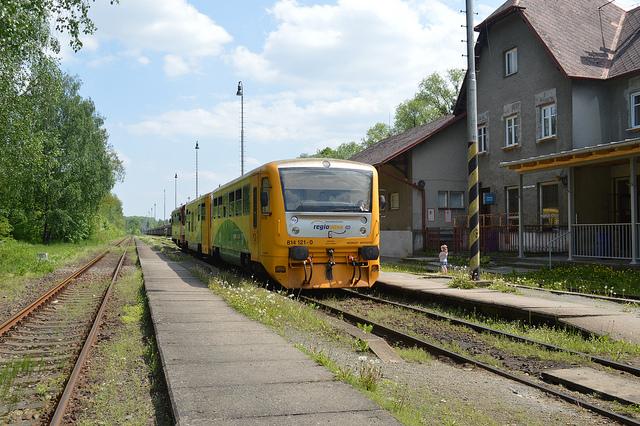How many tracks are in the shot?
Give a very brief answer. 2. Is the train moving fast?
Answer briefly. No. Does the train bother the people in the house?
Quick response, please. Yes. 